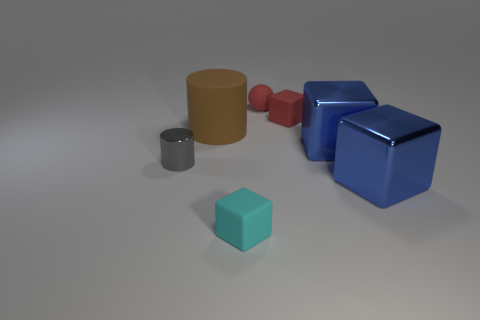Add 1 big metal cubes. How many objects exist? 8 Subtract all cyan blocks. How many blocks are left? 3 Subtract all small red matte cubes. How many cubes are left? 3 Subtract all cubes. How many objects are left? 3 Subtract all cyan cubes. How many cyan cylinders are left? 0 Add 1 rubber cylinders. How many rubber cylinders exist? 2 Subtract 0 green spheres. How many objects are left? 7 Subtract 3 cubes. How many cubes are left? 1 Subtract all red cylinders. Subtract all purple spheres. How many cylinders are left? 2 Subtract all small matte things. Subtract all cyan things. How many objects are left? 3 